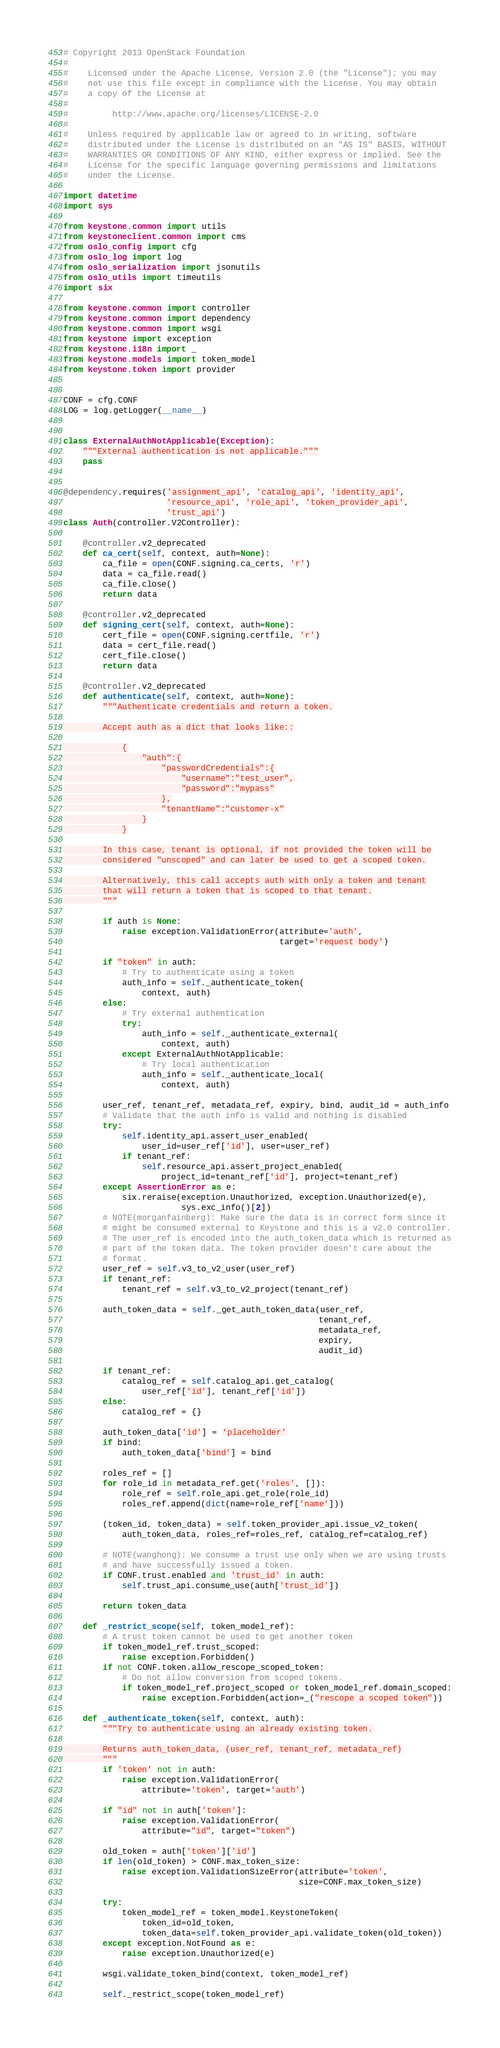<code> <loc_0><loc_0><loc_500><loc_500><_Python_># Copyright 2013 OpenStack Foundation
#
#    Licensed under the Apache License, Version 2.0 (the "License"); you may
#    not use this file except in compliance with the License. You may obtain
#    a copy of the License at
#
#         http://www.apache.org/licenses/LICENSE-2.0
#
#    Unless required by applicable law or agreed to in writing, software
#    distributed under the License is distributed on an "AS IS" BASIS, WITHOUT
#    WARRANTIES OR CONDITIONS OF ANY KIND, either express or implied. See the
#    License for the specific language governing permissions and limitations
#    under the License.

import datetime
import sys

from keystone.common import utils
from keystoneclient.common import cms
from oslo_config import cfg
from oslo_log import log
from oslo_serialization import jsonutils
from oslo_utils import timeutils
import six

from keystone.common import controller
from keystone.common import dependency
from keystone.common import wsgi
from keystone import exception
from keystone.i18n import _
from keystone.models import token_model
from keystone.token import provider


CONF = cfg.CONF
LOG = log.getLogger(__name__)


class ExternalAuthNotApplicable(Exception):
    """External authentication is not applicable."""
    pass


@dependency.requires('assignment_api', 'catalog_api', 'identity_api',
                     'resource_api', 'role_api', 'token_provider_api',
                     'trust_api')
class Auth(controller.V2Controller):

    @controller.v2_deprecated
    def ca_cert(self, context, auth=None):
        ca_file = open(CONF.signing.ca_certs, 'r')
        data = ca_file.read()
        ca_file.close()
        return data

    @controller.v2_deprecated
    def signing_cert(self, context, auth=None):
        cert_file = open(CONF.signing.certfile, 'r')
        data = cert_file.read()
        cert_file.close()
        return data

    @controller.v2_deprecated
    def authenticate(self, context, auth=None):
        """Authenticate credentials and return a token.

        Accept auth as a dict that looks like::

            {
                "auth":{
                    "passwordCredentials":{
                        "username":"test_user",
                        "password":"mypass"
                    },
                    "tenantName":"customer-x"
                }
            }

        In this case, tenant is optional, if not provided the token will be
        considered "unscoped" and can later be used to get a scoped token.

        Alternatively, this call accepts auth with only a token and tenant
        that will return a token that is scoped to that tenant.
        """

        if auth is None:
            raise exception.ValidationError(attribute='auth',
                                            target='request body')

        if "token" in auth:
            # Try to authenticate using a token
            auth_info = self._authenticate_token(
                context, auth)
        else:
            # Try external authentication
            try:
                auth_info = self._authenticate_external(
                    context, auth)
            except ExternalAuthNotApplicable:
                # Try local authentication
                auth_info = self._authenticate_local(
                    context, auth)

        user_ref, tenant_ref, metadata_ref, expiry, bind, audit_id = auth_info
        # Validate that the auth info is valid and nothing is disabled
        try:
            self.identity_api.assert_user_enabled(
                user_id=user_ref['id'], user=user_ref)
            if tenant_ref:
                self.resource_api.assert_project_enabled(
                    project_id=tenant_ref['id'], project=tenant_ref)
        except AssertionError as e:
            six.reraise(exception.Unauthorized, exception.Unauthorized(e),
                        sys.exc_info()[2])
        # NOTE(morganfainberg): Make sure the data is in correct form since it
        # might be consumed external to Keystone and this is a v2.0 controller.
        # The user_ref is encoded into the auth_token_data which is returned as
        # part of the token data. The token provider doesn't care about the
        # format.
        user_ref = self.v3_to_v2_user(user_ref)
        if tenant_ref:
            tenant_ref = self.v3_to_v2_project(tenant_ref)

        auth_token_data = self._get_auth_token_data(user_ref,
                                                    tenant_ref,
                                                    metadata_ref,
                                                    expiry,
                                                    audit_id)

        if tenant_ref:
            catalog_ref = self.catalog_api.get_catalog(
                user_ref['id'], tenant_ref['id'])
        else:
            catalog_ref = {}

        auth_token_data['id'] = 'placeholder'
        if bind:
            auth_token_data['bind'] = bind

        roles_ref = []
        for role_id in metadata_ref.get('roles', []):
            role_ref = self.role_api.get_role(role_id)
            roles_ref.append(dict(name=role_ref['name']))

        (token_id, token_data) = self.token_provider_api.issue_v2_token(
            auth_token_data, roles_ref=roles_ref, catalog_ref=catalog_ref)

        # NOTE(wanghong): We consume a trust use only when we are using trusts
        # and have successfully issued a token.
        if CONF.trust.enabled and 'trust_id' in auth:
            self.trust_api.consume_use(auth['trust_id'])

        return token_data

    def _restrict_scope(self, token_model_ref):
        # A trust token cannot be used to get another token
        if token_model_ref.trust_scoped:
            raise exception.Forbidden()
        if not CONF.token.allow_rescope_scoped_token:
            # Do not allow conversion from scoped tokens.
            if token_model_ref.project_scoped or token_model_ref.domain_scoped:
                raise exception.Forbidden(action=_("rescope a scoped token"))

    def _authenticate_token(self, context, auth):
        """Try to authenticate using an already existing token.

        Returns auth_token_data, (user_ref, tenant_ref, metadata_ref)
        """
        if 'token' not in auth:
            raise exception.ValidationError(
                attribute='token', target='auth')

        if "id" not in auth['token']:
            raise exception.ValidationError(
                attribute="id", target="token")

        old_token = auth['token']['id']
        if len(old_token) > CONF.max_token_size:
            raise exception.ValidationSizeError(attribute='token',
                                                size=CONF.max_token_size)

        try:
            token_model_ref = token_model.KeystoneToken(
                token_id=old_token,
                token_data=self.token_provider_api.validate_token(old_token))
        except exception.NotFound as e:
            raise exception.Unauthorized(e)

        wsgi.validate_token_bind(context, token_model_ref)

        self._restrict_scope(token_model_ref)</code> 